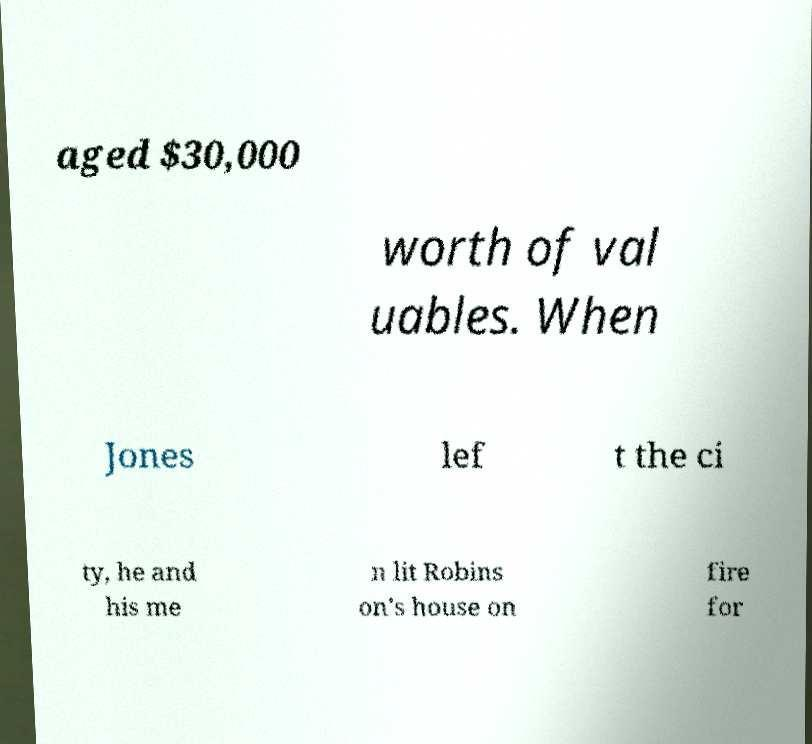I need the written content from this picture converted into text. Can you do that? aged $30,000 worth of val uables. When Jones lef t the ci ty, he and his me n lit Robins on's house on fire for 